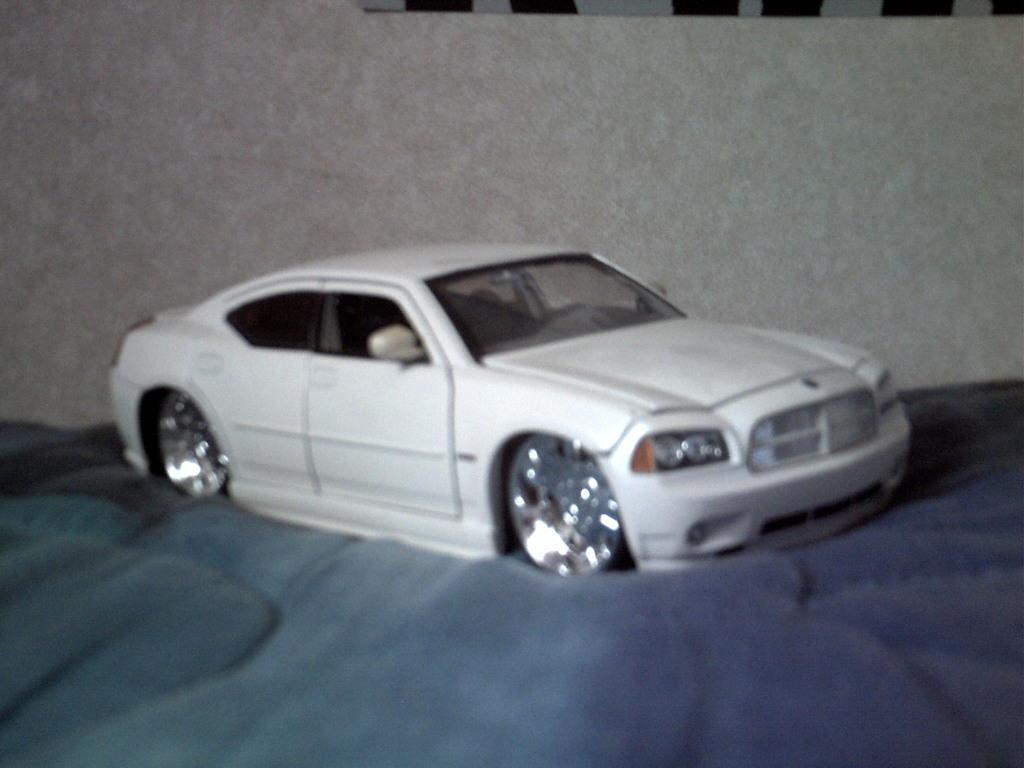How would you summarize this image in a sentence or two? In this image there is a white car. In the background there is a wall. 